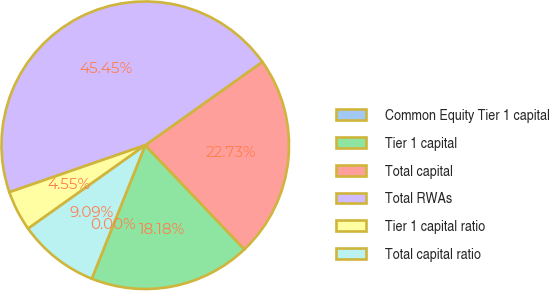Convert chart. <chart><loc_0><loc_0><loc_500><loc_500><pie_chart><fcel>Common Equity Tier 1 capital<fcel>Tier 1 capital<fcel>Total capital<fcel>Total RWAs<fcel>Tier 1 capital ratio<fcel>Total capital ratio<nl><fcel>0.0%<fcel>18.18%<fcel>22.73%<fcel>45.45%<fcel>4.55%<fcel>9.09%<nl></chart> 